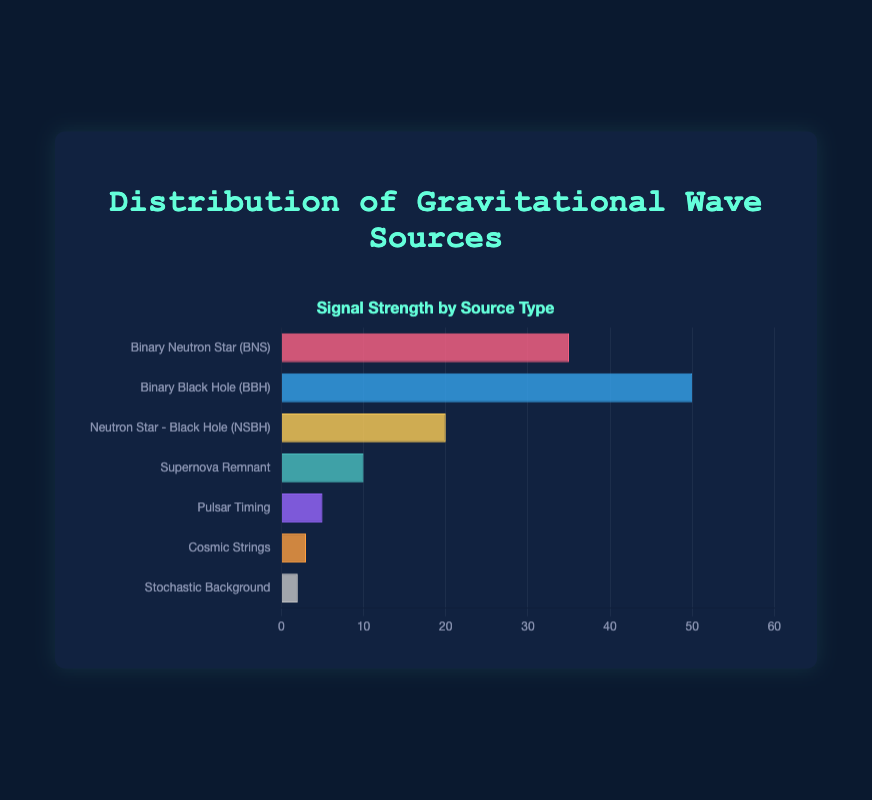What is the source type with the highest signal strength? By looking at the bar chart, we identify the longest bar, which corresponds to the Binary Black Hole (BBH) source type with a signal strength of 50.
Answer: Binary Black Hole (BBH) Which source type has the lowest signal strength? The shortest bar on the chart, representing the Stochastic Background, has the lowest signal strength of 2.
Answer: Stochastic Background How much greater is the signal strength of Binary Black Holes (BBH) compared to Neutron Star - Black Hole (NSBH) systems? The signal strength of BBH is 50, while NSBH is 20. The difference is calculated by subtracting the NSBH strength from the BBH strength: 50 - 20 = 30.
Answer: 30 What is the combined signal strength of Supernova Remnants and Pulsar Timing? Adding the signal strengths of Supernova Remnants (10) and Pulsar Timing (5) yields a total of 10 + 5 = 15.
Answer: 15 Which has a higher signal strength: Binary Neutron Stars (BNS) or Neutron Star - Black Hole (NSBH) systems? Comparing the bars for BNS (35) and NSBH (20), the BNS bar is longer, indicating a higher signal strength.
Answer: Binary Neutron Star (BNS) How many source types have a signal strength greater than 10? By examining the chart, we see three bars higher than the 10 mark: Binary Neutron Star (BNS), Binary Black Hole (BBH), and Neutron Star - Black Hole (NSBH).
Answer: 3 Rank the source types from highest to lowest signal strength. Ordered by the length of bars from longest to shortest: Binary Black Hole (BBH), Binary Neutron Star (BNS), Neutron Star - Black Hole (NSBH), Supernova Remnant, Pulsar Timing, Cosmic Strings, Stochastic Background.
Answer: BBH, BNS, NSBH, Supernova Remnant, Pulsar Timing, Cosmic Strings, Stochastic Background What is the signal strength of Cosmic Strings, and how does it compare to Pulsar Timing? Cosmic Strings have a signal strength of 3, Pulsar Timing has a signal strength of 5. Comparing these, the signal strength of Pulsar Timing is higher by 2.
Answer: Pulsar Timing is higher by 2 Which source type has nearly half the signal strength of Binary Neutron Stars (BNS)? The BNS signal strength is 35. Half of this value is 17.5. The closest signal strength to this value is Neutron Star - Black Hole (NSBH) with a signal strength of 20.
Answer: Neutron Star - Black Hole (NSBH) What is the average signal strength of all source types? Summing the signal strengths: 35 + 50 + 20 + 10 + 5 + 3 + 2 = 125. There are 7 source types. Dividing the total by the number of sources gives the average: 125 / 7 ≈ 17.86.
Answer: 17.86 